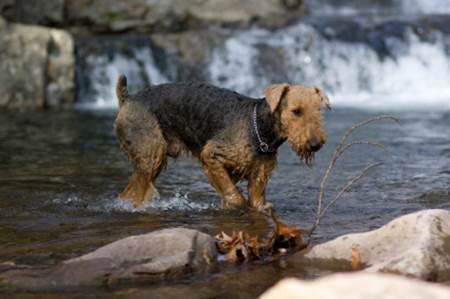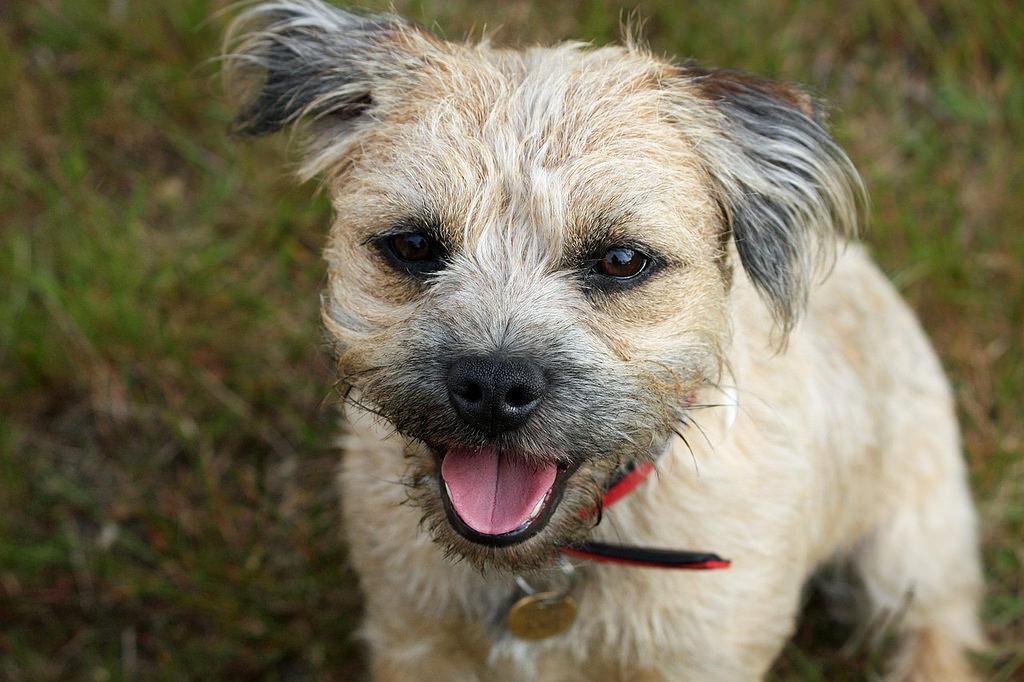The first image is the image on the left, the second image is the image on the right. Considering the images on both sides, is "At least one image shows a body of water behind one dog." valid? Answer yes or no. Yes. 